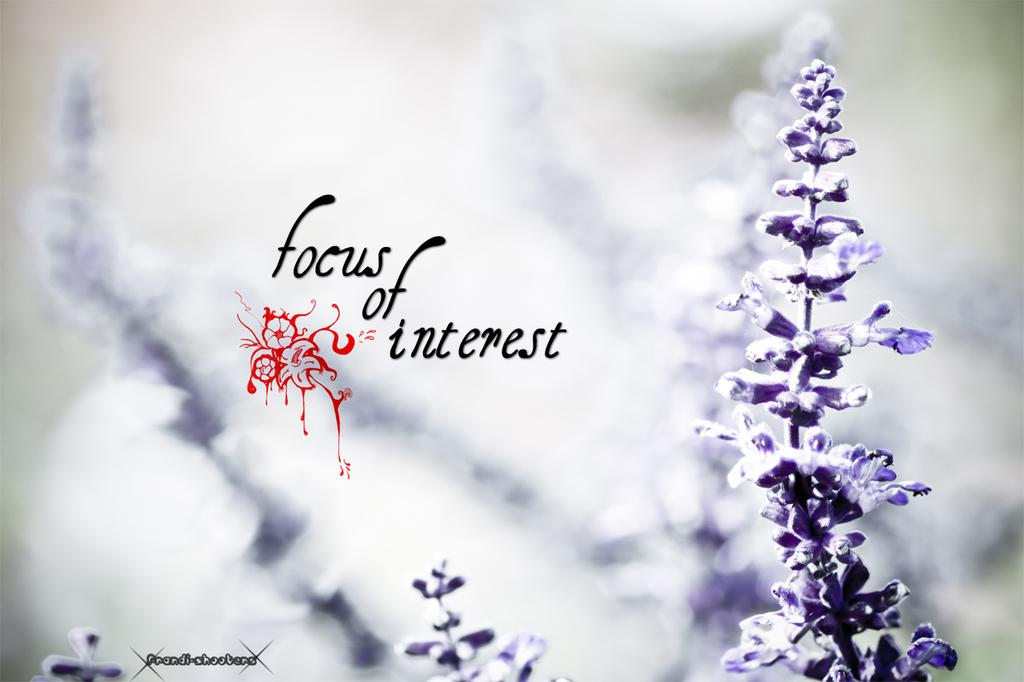What type of living organisms can be seen in the image? There are flowers in the image. Is there any text present on the flowers? Yes, there is text written on the flowers. How would you describe the background of the image? The background of the image is blurred. What type of base can be seen supporting the bear in the image? There is no base or bear present in the image; it features only flowers and text are visible. 